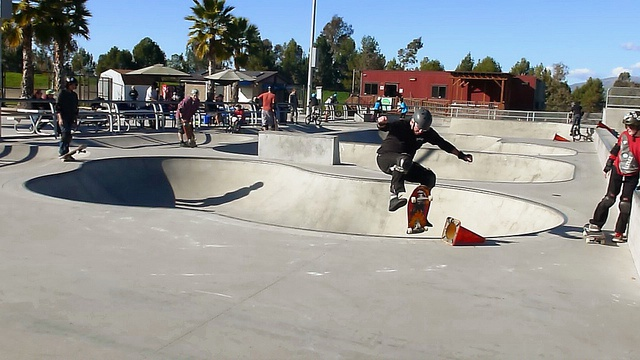Describe the objects in this image and their specific colors. I can see people in gray, black, lightgray, and darkgray tones, people in gray, black, darkgray, and white tones, people in gray, black, maroon, and darkgray tones, people in gray, black, darkgray, and lightgray tones, and skateboard in gray, maroon, black, and ivory tones in this image. 